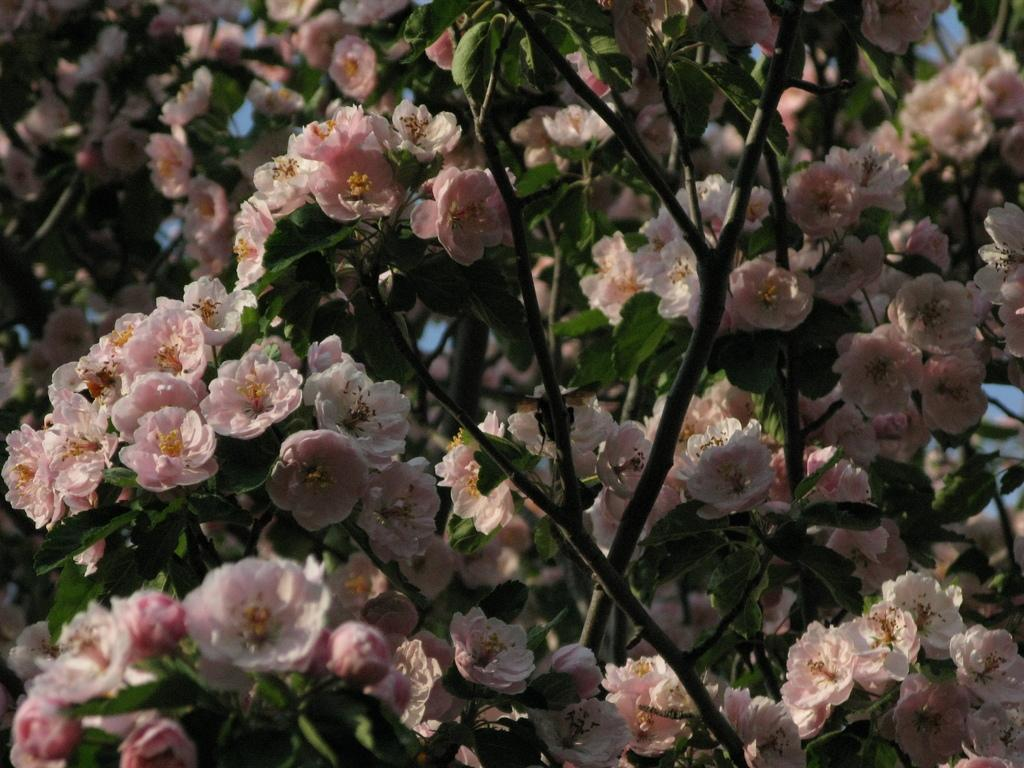What celestial bodies are depicted in the image? There are planets in the image. What type of flora can be seen in the image? There are pink flowers in the image. What type of map is visible in the image? There is no map present in the image. What question is being asked by the planets in the image? The planets are not capable of asking questions, as they are celestial bodies and not living beings. 